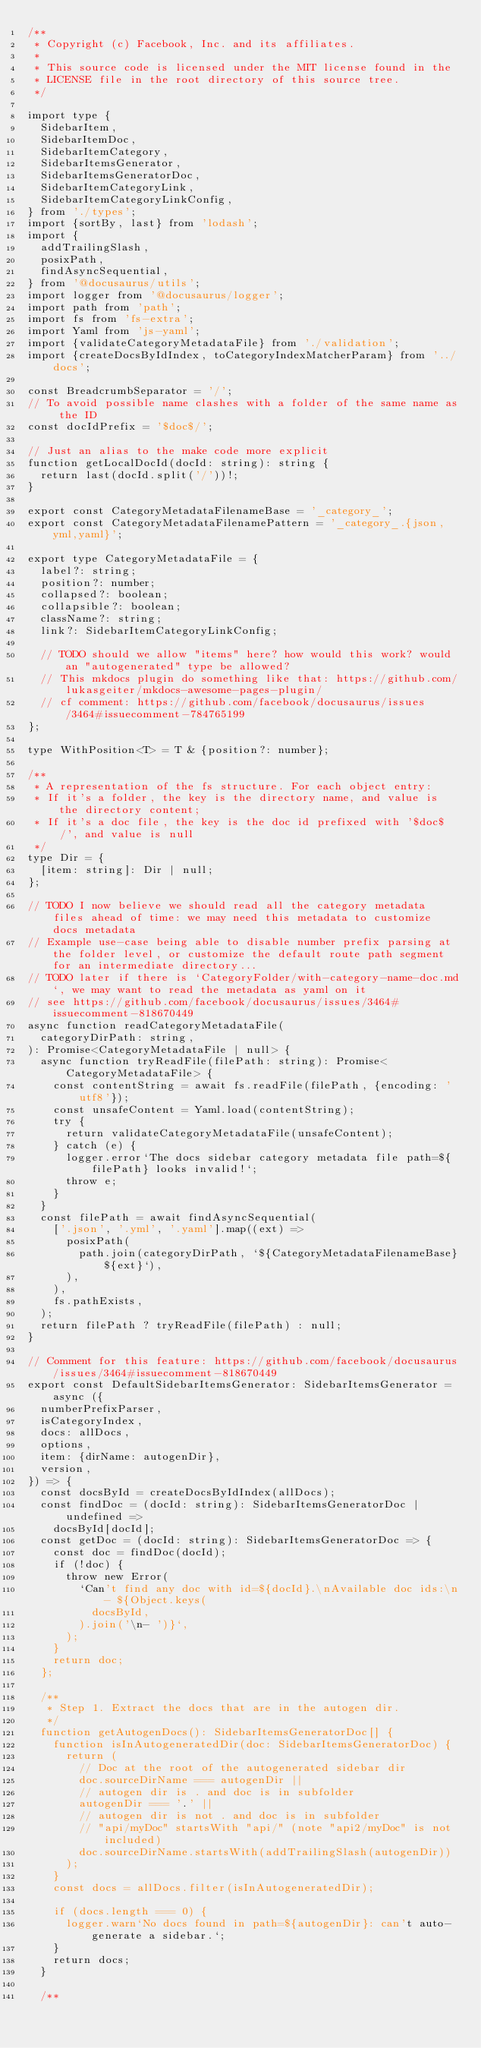<code> <loc_0><loc_0><loc_500><loc_500><_TypeScript_>/**
 * Copyright (c) Facebook, Inc. and its affiliates.
 *
 * This source code is licensed under the MIT license found in the
 * LICENSE file in the root directory of this source tree.
 */

import type {
  SidebarItem,
  SidebarItemDoc,
  SidebarItemCategory,
  SidebarItemsGenerator,
  SidebarItemsGeneratorDoc,
  SidebarItemCategoryLink,
  SidebarItemCategoryLinkConfig,
} from './types';
import {sortBy, last} from 'lodash';
import {
  addTrailingSlash,
  posixPath,
  findAsyncSequential,
} from '@docusaurus/utils';
import logger from '@docusaurus/logger';
import path from 'path';
import fs from 'fs-extra';
import Yaml from 'js-yaml';
import {validateCategoryMetadataFile} from './validation';
import {createDocsByIdIndex, toCategoryIndexMatcherParam} from '../docs';

const BreadcrumbSeparator = '/';
// To avoid possible name clashes with a folder of the same name as the ID
const docIdPrefix = '$doc$/';

// Just an alias to the make code more explicit
function getLocalDocId(docId: string): string {
  return last(docId.split('/'))!;
}

export const CategoryMetadataFilenameBase = '_category_';
export const CategoryMetadataFilenamePattern = '_category_.{json,yml,yaml}';

export type CategoryMetadataFile = {
  label?: string;
  position?: number;
  collapsed?: boolean;
  collapsible?: boolean;
  className?: string;
  link?: SidebarItemCategoryLinkConfig;

  // TODO should we allow "items" here? how would this work? would an "autogenerated" type be allowed?
  // This mkdocs plugin do something like that: https://github.com/lukasgeiter/mkdocs-awesome-pages-plugin/
  // cf comment: https://github.com/facebook/docusaurus/issues/3464#issuecomment-784765199
};

type WithPosition<T> = T & {position?: number};

/**
 * A representation of the fs structure. For each object entry:
 * If it's a folder, the key is the directory name, and value is the directory content;
 * If it's a doc file, the key is the doc id prefixed with '$doc$/', and value is null
 */
type Dir = {
  [item: string]: Dir | null;
};

// TODO I now believe we should read all the category metadata files ahead of time: we may need this metadata to customize docs metadata
// Example use-case being able to disable number prefix parsing at the folder level, or customize the default route path segment for an intermediate directory...
// TODO later if there is `CategoryFolder/with-category-name-doc.md`, we may want to read the metadata as yaml on it
// see https://github.com/facebook/docusaurus/issues/3464#issuecomment-818670449
async function readCategoryMetadataFile(
  categoryDirPath: string,
): Promise<CategoryMetadataFile | null> {
  async function tryReadFile(filePath: string): Promise<CategoryMetadataFile> {
    const contentString = await fs.readFile(filePath, {encoding: 'utf8'});
    const unsafeContent = Yaml.load(contentString);
    try {
      return validateCategoryMetadataFile(unsafeContent);
    } catch (e) {
      logger.error`The docs sidebar category metadata file path=${filePath} looks invalid!`;
      throw e;
    }
  }
  const filePath = await findAsyncSequential(
    ['.json', '.yml', '.yaml'].map((ext) =>
      posixPath(
        path.join(categoryDirPath, `${CategoryMetadataFilenameBase}${ext}`),
      ),
    ),
    fs.pathExists,
  );
  return filePath ? tryReadFile(filePath) : null;
}

// Comment for this feature: https://github.com/facebook/docusaurus/issues/3464#issuecomment-818670449
export const DefaultSidebarItemsGenerator: SidebarItemsGenerator = async ({
  numberPrefixParser,
  isCategoryIndex,
  docs: allDocs,
  options,
  item: {dirName: autogenDir},
  version,
}) => {
  const docsById = createDocsByIdIndex(allDocs);
  const findDoc = (docId: string): SidebarItemsGeneratorDoc | undefined =>
    docsById[docId];
  const getDoc = (docId: string): SidebarItemsGeneratorDoc => {
    const doc = findDoc(docId);
    if (!doc) {
      throw new Error(
        `Can't find any doc with id=${docId}.\nAvailable doc ids:\n- ${Object.keys(
          docsById,
        ).join('\n- ')}`,
      );
    }
    return doc;
  };

  /**
   * Step 1. Extract the docs that are in the autogen dir.
   */
  function getAutogenDocs(): SidebarItemsGeneratorDoc[] {
    function isInAutogeneratedDir(doc: SidebarItemsGeneratorDoc) {
      return (
        // Doc at the root of the autogenerated sidebar dir
        doc.sourceDirName === autogenDir ||
        // autogen dir is . and doc is in subfolder
        autogenDir === '.' ||
        // autogen dir is not . and doc is in subfolder
        // "api/myDoc" startsWith "api/" (note "api2/myDoc" is not included)
        doc.sourceDirName.startsWith(addTrailingSlash(autogenDir))
      );
    }
    const docs = allDocs.filter(isInAutogeneratedDir);

    if (docs.length === 0) {
      logger.warn`No docs found in path=${autogenDir}: can't auto-generate a sidebar.`;
    }
    return docs;
  }

  /**</code> 